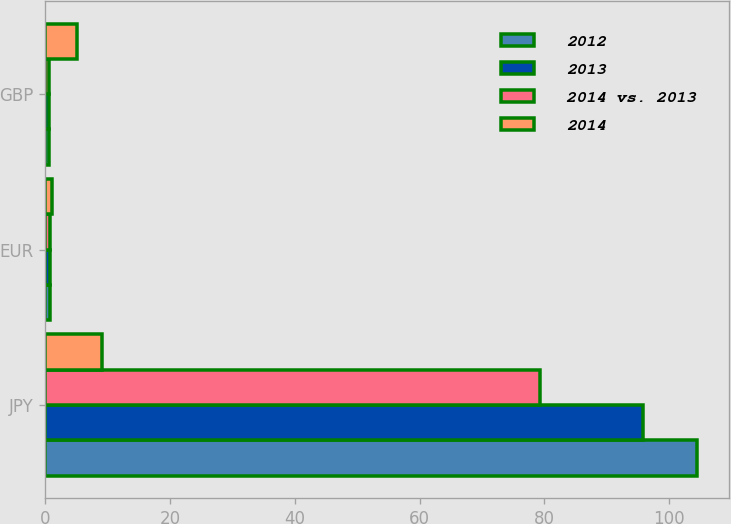Convert chart to OTSL. <chart><loc_0><loc_0><loc_500><loc_500><stacked_bar_chart><ecel><fcel>JPY<fcel>EUR<fcel>GBP<nl><fcel>2012<fcel>104.43<fcel>0.75<fcel>0.61<nl><fcel>2013<fcel>95.86<fcel>0.76<fcel>0.64<nl><fcel>2014 vs. 2013<fcel>79.32<fcel>0.78<fcel>0.63<nl><fcel>2014<fcel>9<fcel>1<fcel>5<nl></chart> 